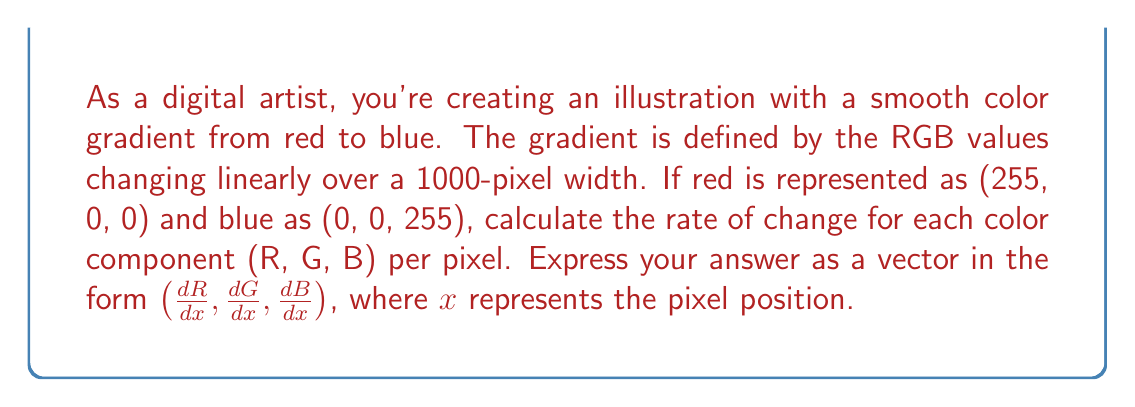Help me with this question. To solve this problem, we need to analyze the change in each color component (R, G, B) over the given pixel range. Let's break it down step by step:

1. Identify the start and end points:
   - Start (red): (255, 0, 0)
   - End (blue): (0, 0, 255)

2. Calculate the total change for each component:
   - $\Delta R = 0 - 255 = -255$
   - $\Delta G = 0 - 0 = 0$
   - $\Delta B = 255 - 0 = 255$

3. Determine the range of pixels:
   - Total width = 1000 pixels

4. Calculate the rate of change for each component:
   - For R: $\frac{dR}{dx} = \frac{\Delta R}{\text{pixel range}} = \frac{-255}{1000} = -0.255$
   - For G: $\frac{dG}{dx} = \frac{\Delta G}{\text{pixel range}} = \frac{0}{1000} = 0$
   - For B: $\frac{dB}{dx} = \frac{\Delta B}{\text{pixel range}} = \frac{255}{1000} = 0.255$

5. Express the result as a vector:
   $(\frac{dR}{dx}, \frac{dG}{dx}, \frac{dB}{dx}) = (-0.255, 0, 0.255)$

This vector represents the rate of change for each color component per pixel in the gradient.
Answer: $(-0.255, 0, 0.255)$ 